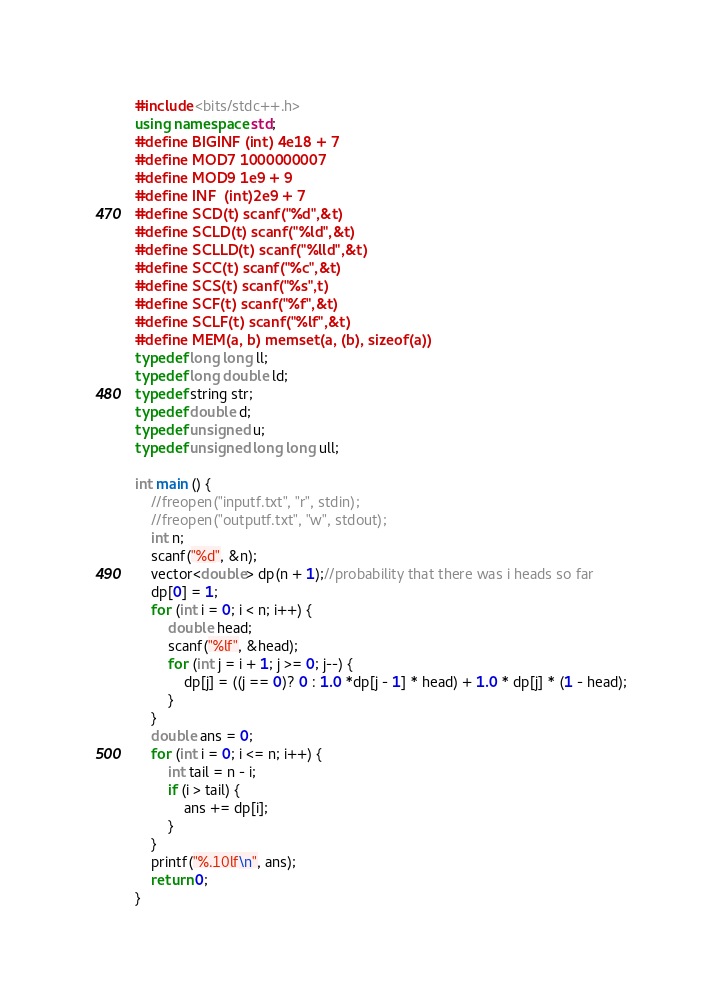Convert code to text. <code><loc_0><loc_0><loc_500><loc_500><_C++_>#include <bits/stdc++.h>
using namespace std;
#define BIGINF (int) 4e18 + 7
#define MOD7 1000000007
#define MOD9 1e9 + 9
#define INF  (int)2e9 + 7
#define SCD(t) scanf("%d",&t)
#define SCLD(t) scanf("%ld",&t)
#define SCLLD(t) scanf("%lld",&t)
#define SCC(t) scanf("%c",&t)
#define SCS(t) scanf("%s",t)
#define SCF(t) scanf("%f",&t)
#define SCLF(t) scanf("%lf",&t)
#define MEM(a, b) memset(a, (b), sizeof(a))
typedef long long ll;
typedef long double ld;
typedef string str;
typedef double d;
typedef unsigned u;
typedef unsigned long long ull;

int main () {
    //freopen("inputf.txt", "r", stdin);
    //freopen("outputf.txt", "w", stdout);
    int n;
    scanf("%d", &n);
    vector<double> dp(n + 1);//probability that there was i heads so far
    dp[0] = 1;
    for (int i = 0; i < n; i++) {
    	double head;
    	scanf("%lf", &head);
    	for (int j = i + 1; j >= 0; j--) { 
    		dp[j] = ((j == 0)? 0 : 1.0 *dp[j - 1] * head) + 1.0 * dp[j] * (1 - head); 
    	}
    }
    double ans = 0;
    for (int i = 0; i <= n; i++) {
        int tail = n - i;
        if (i > tail) {
            ans += dp[i];        
        }
    } 
    printf("%.10lf\n", ans);
    return 0;
}

</code> 